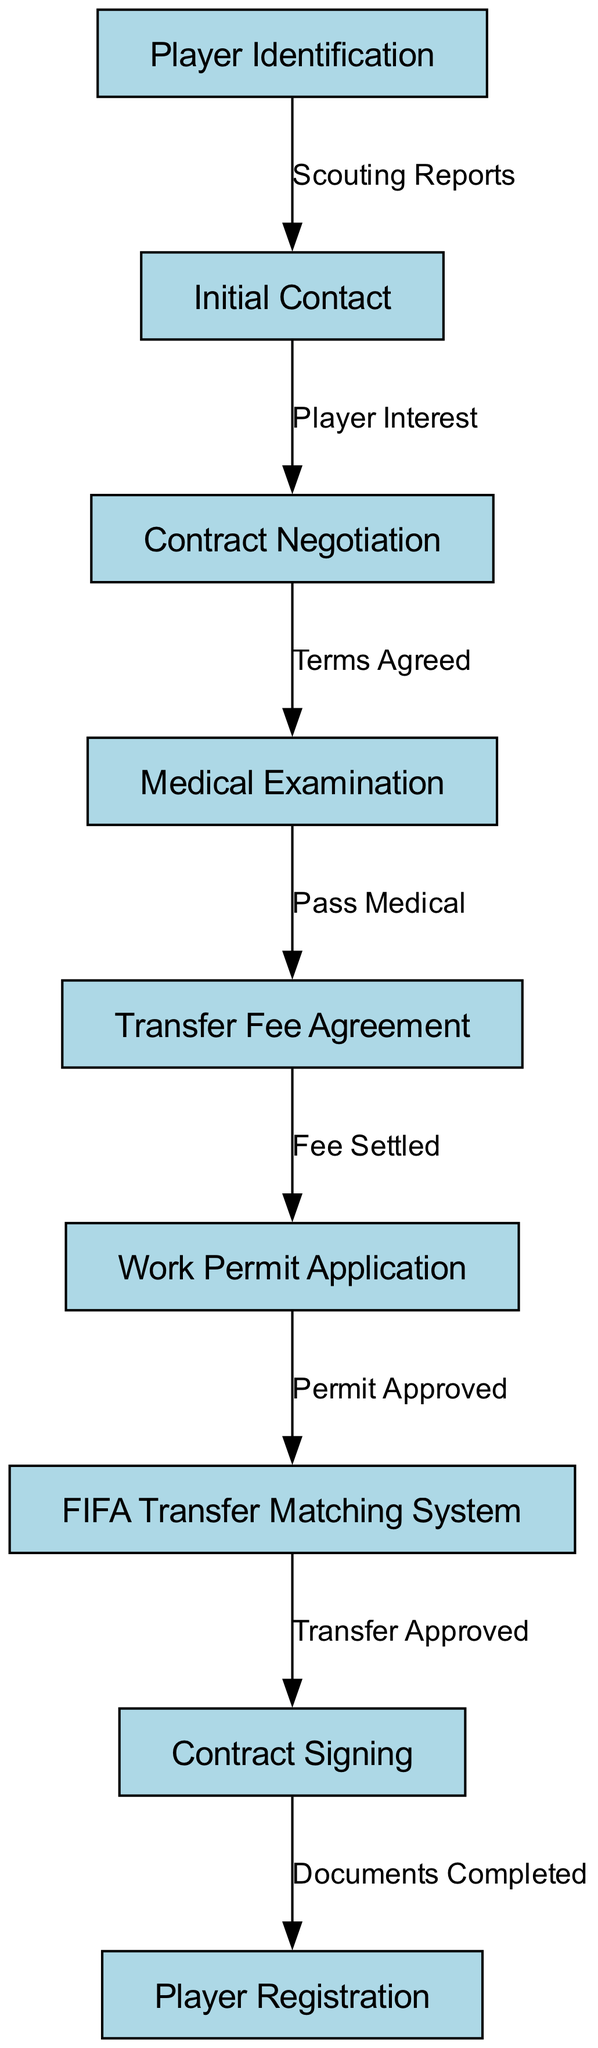What is the first step in the transfer process? The first step is "Player Identification," which is the starting node that initiates the overall flow of the transfer process as shown in the diagram.
Answer: Player Identification How many nodes are present in the diagram? The diagram contains 9 nodes, which represent different stages or steps involved in the transfer process workflow for international football players.
Answer: 9 What does the edge labeled "Terms Agreed" connect? The edge labeled "Terms Agreed" connects "Contract Negotiation" to "Medical Examination," indicating that these two steps are directly linked through this agreement.
Answer: Contract Negotiation to Medical Examination What step follows the "Work Permit Application"? The step that follows "Work Permit Application" is "FIFA Transfer Matching System," which signifies the next action after the permit application is made.
Answer: FIFA Transfer Matching System What must happen before "Contract Signing"? Before "Contract Signing," the "FIFA Transfer Matching System" must approve the transfer, which is a crucial step in finalizing the transfer agreement.
Answer: FIFA Transfer Matching System must approve the transfer How many edges are in the diagram? The diagram has 8 edges, which represent the connections and relationships between the various nodes in the transfer process workflow.
Answer: 8 What indicates that the transfer has been approved? The approval of the transfer is indicated by the edge from "FIFA Transfer Matching System" to "Contract Signing," labeled as "Transfer Approved."
Answer: Transfer Approved What action occurs after "Medical Examination"? After "Medical Examination," the action that occurs is the "Transfer Fee Agreement," which takes place as the next logical step if the medical is passed.
Answer: Transfer Fee Agreement What signifies the completion of the player transfer process? The completion of the player transfer process is signified by "Player Registration," which is the final step that ensures the player is registered with the new club.
Answer: Player Registration 